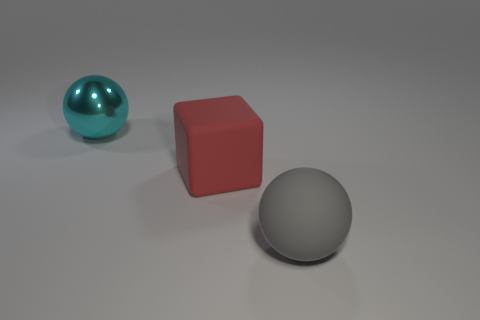Add 2 tiny blue metal cylinders. How many objects exist? 5 Subtract all cubes. How many objects are left? 2 Subtract all large balls. Subtract all large cyan shiny things. How many objects are left? 0 Add 3 big red things. How many big red things are left? 4 Add 1 gray things. How many gray things exist? 2 Subtract 0 red cylinders. How many objects are left? 3 